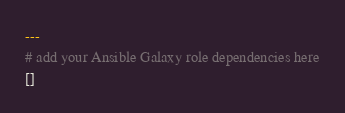<code> <loc_0><loc_0><loc_500><loc_500><_YAML_>---
# add your Ansible Galaxy role dependencies here
[]
</code> 